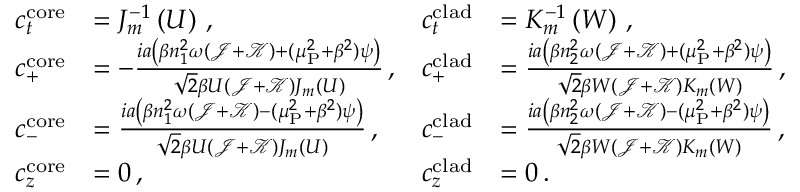Convert formula to latex. <formula><loc_0><loc_0><loc_500><loc_500>\begin{array} { r l r l } { c _ { t } ^ { c o r e } } & { = J _ { m } ^ { - 1 } \left ( U \right ) \, , } & { c _ { t } ^ { c l a d } } & { = K _ { m } ^ { - 1 } \left ( W \right ) \, , } \\ { c _ { + } ^ { c o r e } } & { = - \frac { i a \left ( \beta n _ { 1 } ^ { 2 } \omega ( \mathcal { J } + \mathcal { K } ) + ( \mu _ { P } ^ { 2 } + \beta ^ { 2 } ) \psi \right ) } { \sqrt { 2 } \beta U ( \mathcal { J } + \mathcal { K } ) J _ { m } ( U ) } \, , } & { c _ { + } ^ { c l a d } } & { = \frac { i a \left ( \beta n _ { 2 } ^ { 2 } \omega ( \mathcal { J } + \mathcal { K } ) + ( \mu _ { P } ^ { 2 } + \beta ^ { 2 } ) \psi \right ) } { \sqrt { 2 } \beta W ( \mathcal { J } + \mathcal { K } ) K _ { m } ( W ) } \, , } \\ { c _ { - } ^ { c o r e } } & { = \frac { i a \left ( \beta n _ { 1 } ^ { 2 } \omega ( \mathcal { J } + \mathcal { K } ) - ( \mu _ { P } ^ { 2 } + \beta ^ { 2 } ) \psi \right ) } { \sqrt { 2 } \beta U ( \mathcal { J } + \mathcal { K } ) J _ { m } ( U ) } \, , } & { c _ { - } ^ { c l a d } } & { = \frac { i a \left ( \beta n _ { 2 } ^ { 2 } \omega ( \mathcal { J } + \mathcal { K } ) - ( \mu _ { P } ^ { 2 } + \beta ^ { 2 } ) \psi \right ) } { \sqrt { 2 } \beta W ( \mathcal { J } + \mathcal { K } ) K _ { m } ( W ) } \, , } \\ { c _ { z } ^ { c o r e } } & { = 0 \, , } & { c _ { z } ^ { c l a d } } & { = 0 \, . } \end{array}</formula> 